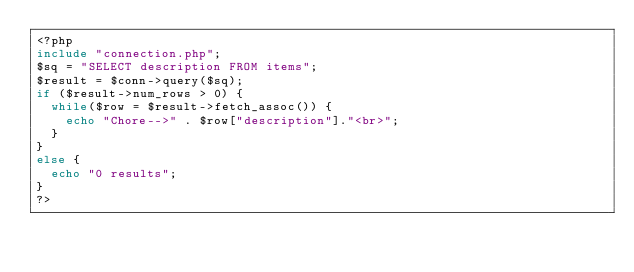<code> <loc_0><loc_0><loc_500><loc_500><_PHP_><?php
include "connection.php";
$sq = "SELECT description FROM items";
$result = $conn->query($sq);
if ($result->num_rows > 0) {
  while($row = $result->fetch_assoc()) {
    echo "Chore-->" . $row["description"]."<br>";
  }
} 
else {
  echo "0 results";
}
?></code> 